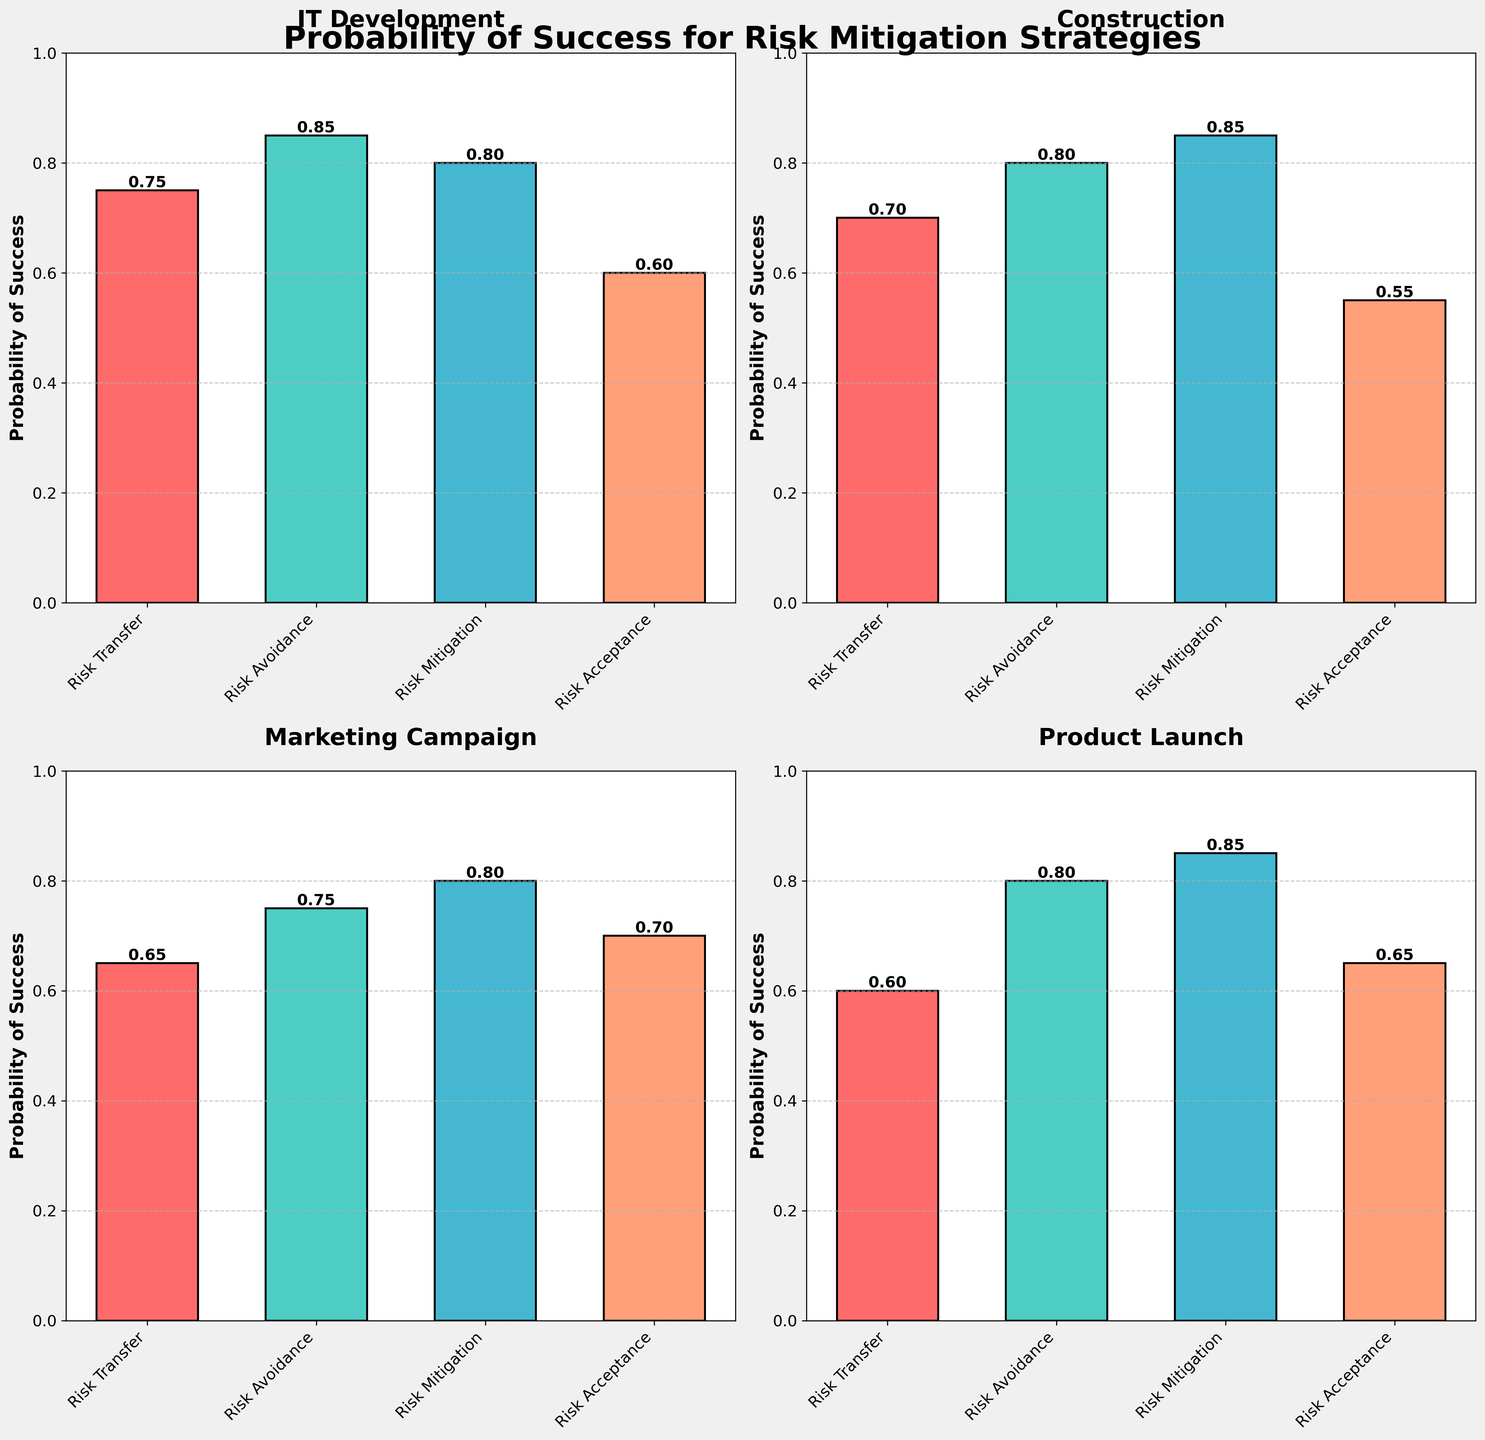What is the highest probability of success for the IT Development project type? The highest bar in the IT Development subplot corresponds to the Risk Avoidance strategy with a probability of 0.85.
Answer: 0.85 What is the average probability of success for risk mitigation strategies in the Construction project type? The probabilities for Construction are: Risk Transfer (0.70), Risk Avoidance (0.80), Risk Mitigation (0.85), and Risk Acceptance (0.55). The average is (0.70 + 0.80 + 0.85 + 0.55) / 4 = 2.90 / 4 = 0.725.
Answer: 0.725 Which risk mitigation strategy has the lowest probability of success in the Marketing Campaign project type, and what is its value? The shortest bar in the Marketing Campaign subplot corresponds to the Risk Transfer strategy with a probability of 0.65.
Answer: Risk Transfer, 0.65 How much higher is the probability of success for Risk Mitigation compared to Risk Acceptance in the Product Launch project type? For the Product Launch project type, Risk Mitigation has a probability of 0.85 and Risk Acceptance has 0.65. The difference is 0.85 - 0.65 = 0.20.
Answer: 0.20 Which project type exhibits the greatest variance in probabilities of success across the strategies? In the subplot, you can see that the Construction project type has a wide range between the highest (0.85 for Risk Mitigation) and the lowest (0.55 for Risk Acceptance) probabilities, resulting in the greatest variance.
Answer: Construction Between IT Development and Construction, which project type has a higher probability of success for Risk Transfer strategy and by how much? For IT Development, the Risk Transfer probability is 0.75. For Construction, it is 0.70. The difference is 0.75 - 0.70 = 0.05.
Answer: IT Development, 0.05 What is the total probability of success for all strategies in the Marketing Campaign project type? The probabilities for Marketing Campaign are: Risk Transfer (0.65), Risk Avoidance (0.75), Risk Mitigation (0.80), and Risk Acceptance (0.70). The total is 0.65 + 0.75 + 0.80 + 0.70 = 2.90.
Answer: 2.90 Which risk mitigation strategy has the most consistent probability of success across all project types? Risk Mitigation consistently shows high probabilities across IT Development (0.80), Construction (0.85), Marketing Campaign (0.80), and Product Launch (0.85).
Answer: Risk Mitigation 